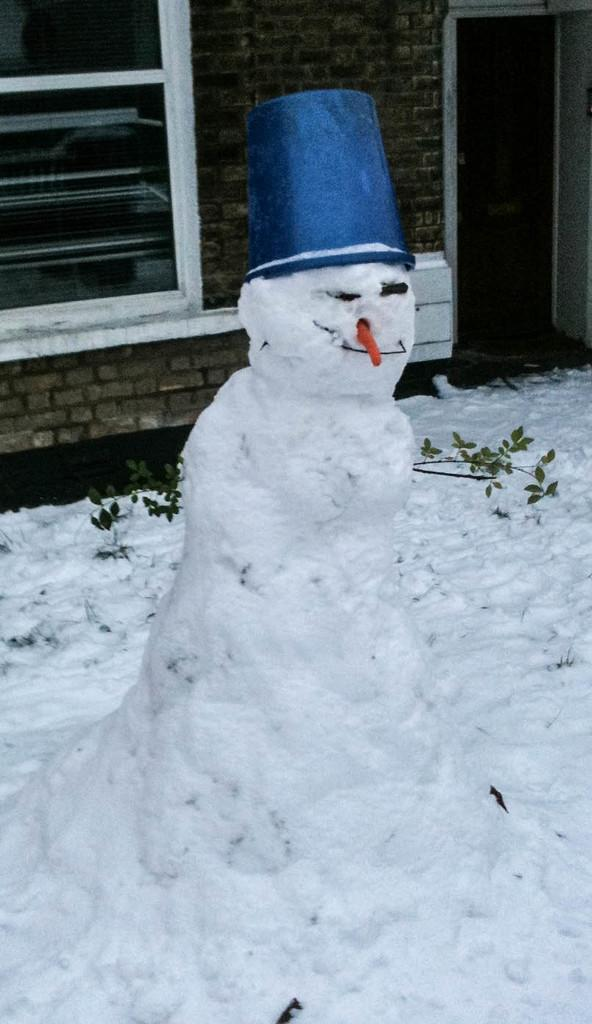What is the main subject in the picture? There is a snowman in the picture. What is the snowman wearing? The snowman is wearing a hat. What can be seen in the background of the picture? There is a wall in the background of the picture. What features does the wall have? The wall has a door and a window. What type of lock is used on the door in the image? There is no lock visible on the door in the image. What kind of experience does the snowman have with building structures? The image does not provide any information about the snowman's experience with building structures. 